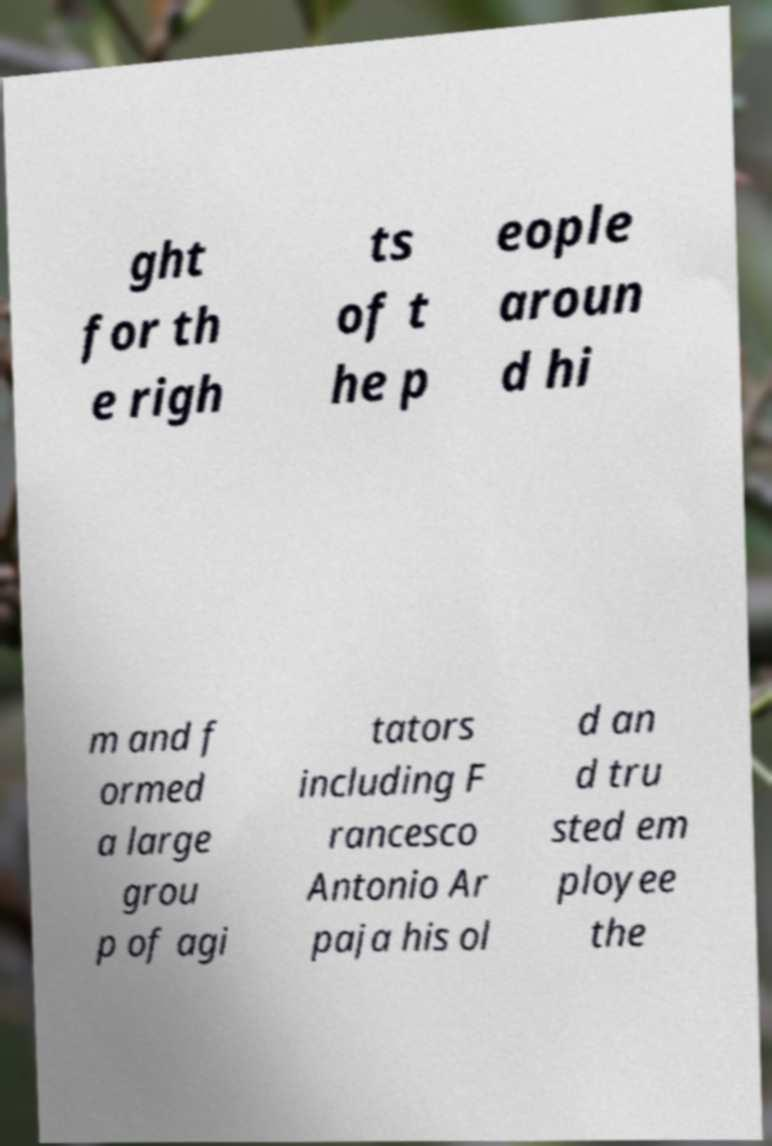Please identify and transcribe the text found in this image. ght for th e righ ts of t he p eople aroun d hi m and f ormed a large grou p of agi tators including F rancesco Antonio Ar paja his ol d an d tru sted em ployee the 